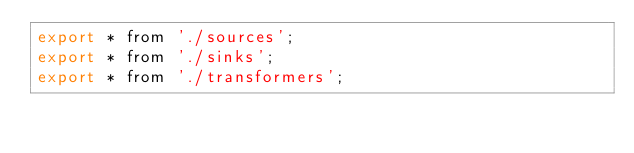Convert code to text. <code><loc_0><loc_0><loc_500><loc_500><_JavaScript_>export * from './sources';
export * from './sinks';
export * from './transformers';
</code> 